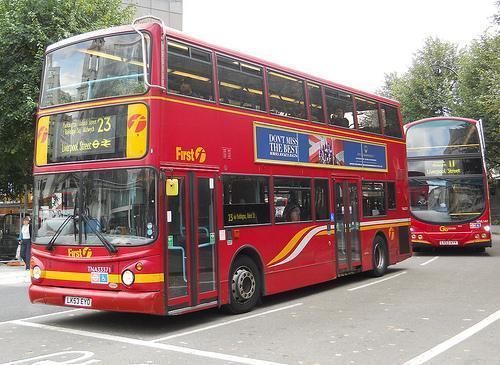How many buses are there?
Give a very brief answer. 2. 